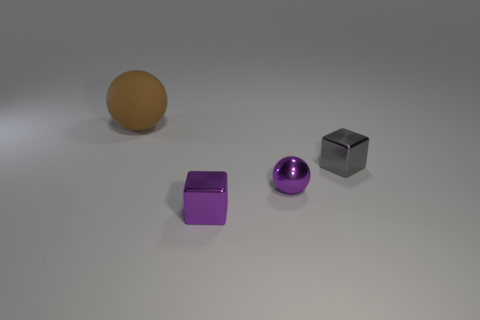Add 3 yellow things. How many objects exist? 7 Subtract 2 balls. How many balls are left? 0 Add 3 tiny green blocks. How many tiny green blocks exist? 3 Subtract 0 blue blocks. How many objects are left? 4 Subtract all blue spheres. Subtract all yellow cylinders. How many spheres are left? 2 Subtract all purple metallic objects. Subtract all green metallic cylinders. How many objects are left? 2 Add 2 shiny blocks. How many shiny blocks are left? 4 